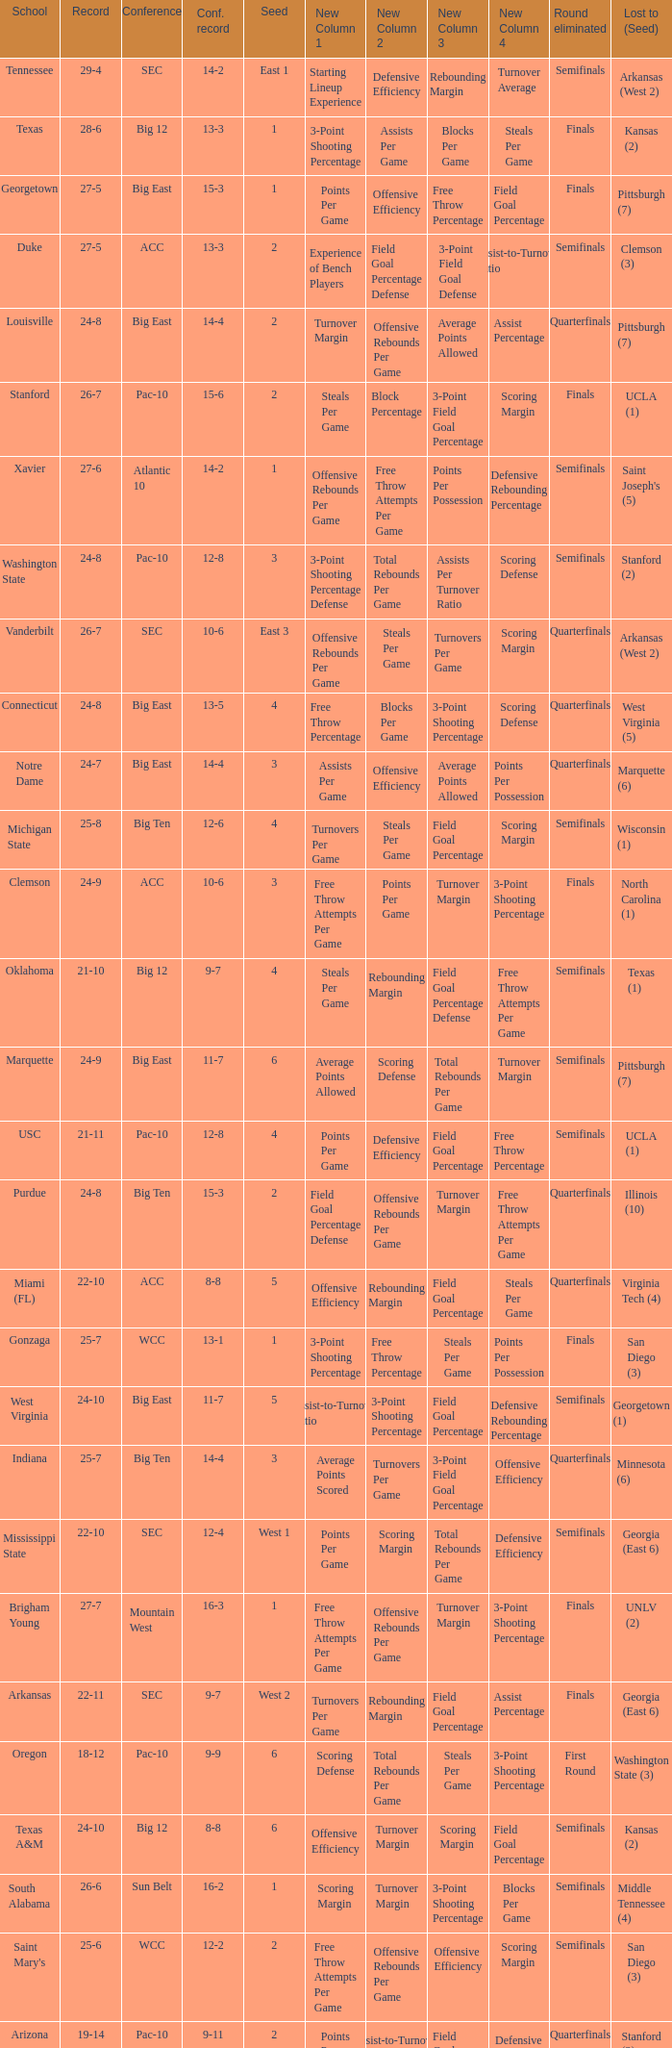Name the conference record where seed is 3 and record is 24-9 10-6. 